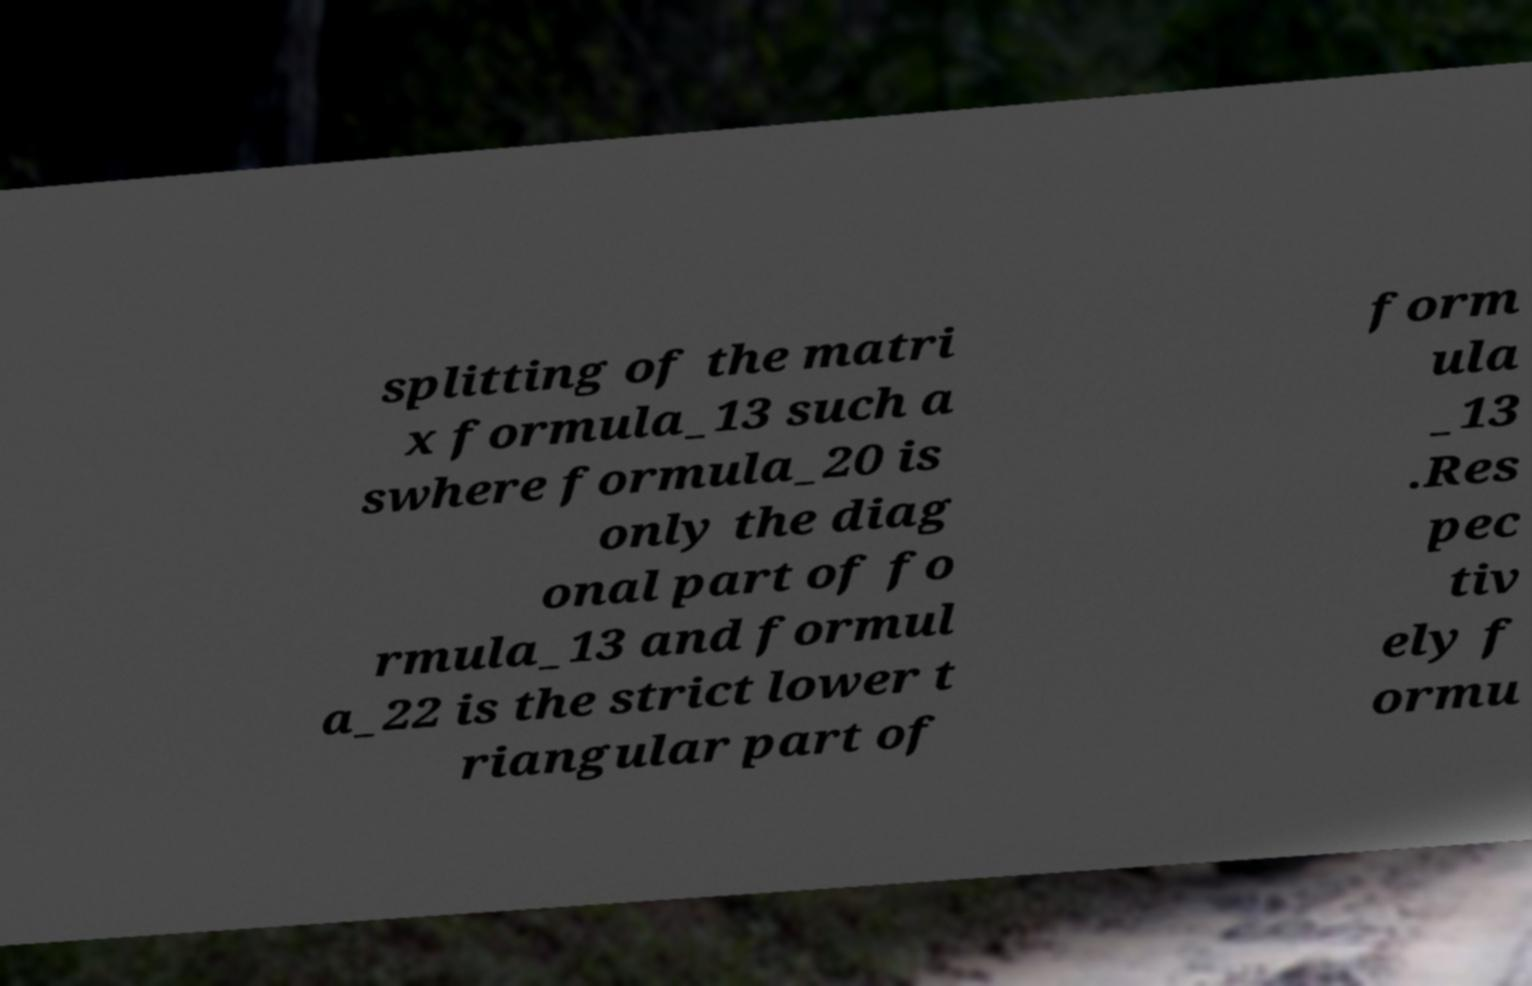Can you read and provide the text displayed in the image?This photo seems to have some interesting text. Can you extract and type it out for me? splitting of the matri x formula_13 such a swhere formula_20 is only the diag onal part of fo rmula_13 and formul a_22 is the strict lower t riangular part of form ula _13 .Res pec tiv ely f ormu 